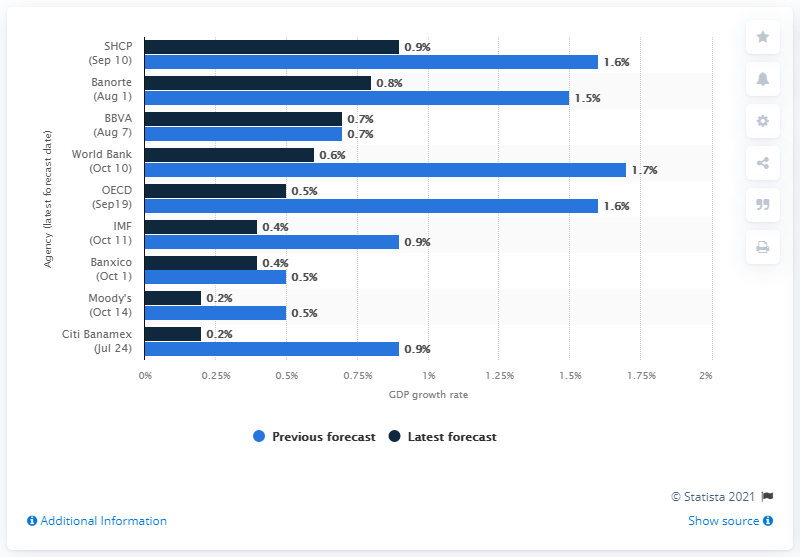Identify some key points in this picture. By the end of 2019, the Mexican economy was forecasted to have a growth rate of 0.9%. 